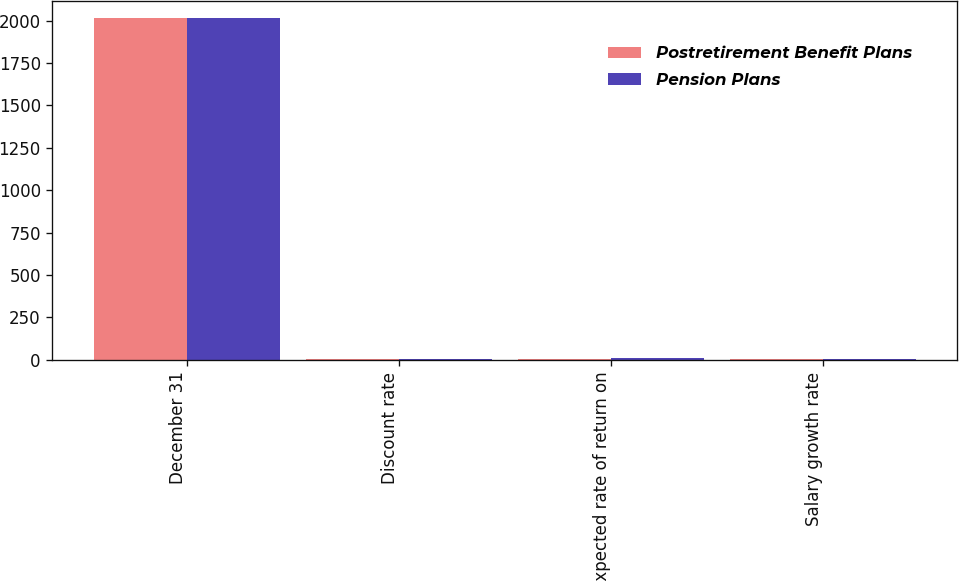Convert chart to OTSL. <chart><loc_0><loc_0><loc_500><loc_500><stacked_bar_chart><ecel><fcel>December 31<fcel>Discount rate<fcel>Expected rate of return on<fcel>Salary growth rate<nl><fcel>Postretirement Benefit Plans<fcel>2013<fcel>3.9<fcel>7.5<fcel>4.2<nl><fcel>Pension Plans<fcel>2013<fcel>4.1<fcel>8.5<fcel>4.5<nl></chart> 